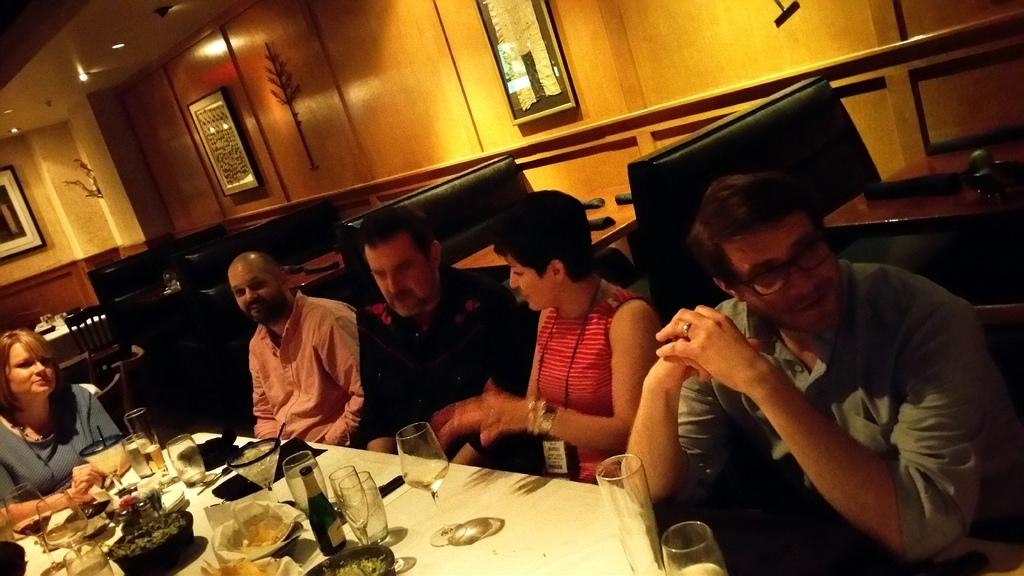What are the people in the image doing? The people in the image are sitting. What objects can be seen on the table in the image? There are glasses and a bowl of food on the table. What is hanging on the wall in the image? There are frames on the wall. What type of pancake is the farmer holding in the image? There is no pancake or farmer present in the image. How much money is on the table in the image? There is no money visible in the image. 